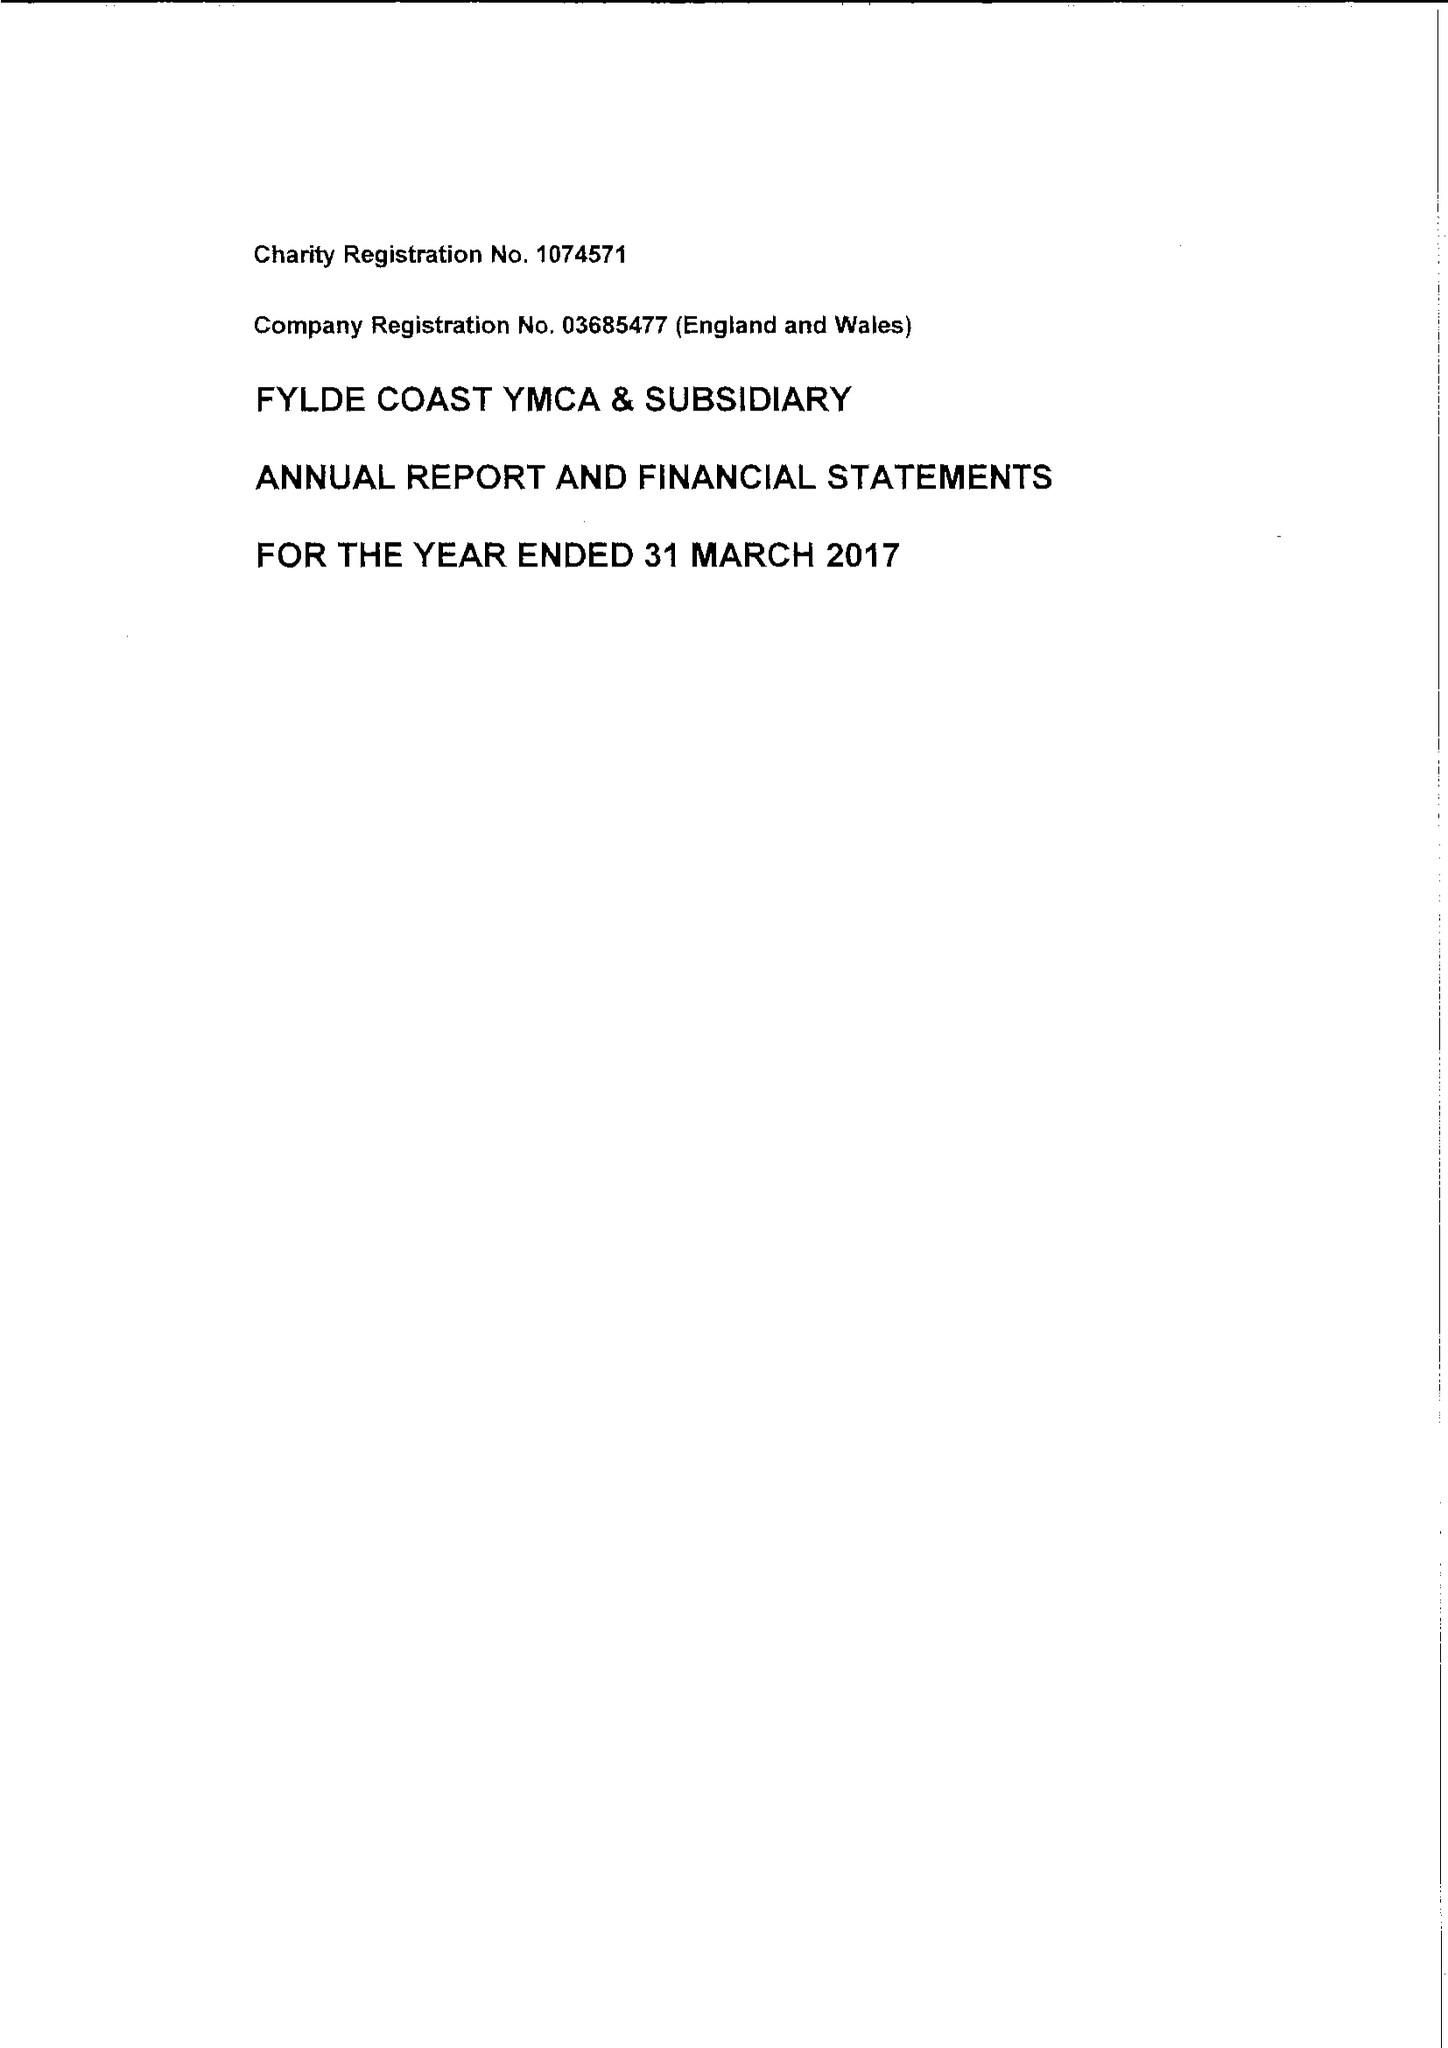What is the value for the report_date?
Answer the question using a single word or phrase. 2017-03-31 